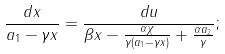<formula> <loc_0><loc_0><loc_500><loc_500>\frac { d x } { a _ { 1 } - \gamma x } = \frac { d u } { \beta x - \frac { \alpha \chi } { \gamma ( a _ { 1 } - \gamma x ) } + \frac { \alpha a _ { 2 } } { \gamma } } ;</formula> 